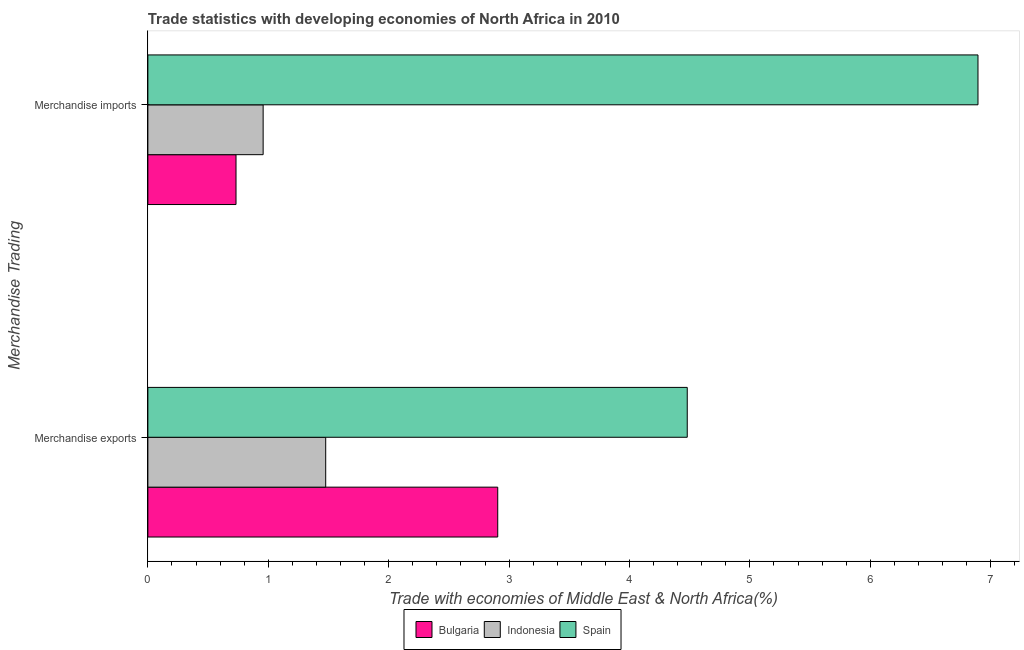How many different coloured bars are there?
Ensure brevity in your answer.  3. How many groups of bars are there?
Your answer should be compact. 2. Are the number of bars per tick equal to the number of legend labels?
Provide a succinct answer. Yes. Are the number of bars on each tick of the Y-axis equal?
Ensure brevity in your answer.  Yes. How many bars are there on the 1st tick from the bottom?
Offer a very short reply. 3. What is the label of the 2nd group of bars from the top?
Provide a short and direct response. Merchandise exports. What is the merchandise imports in Indonesia?
Give a very brief answer. 0.96. Across all countries, what is the maximum merchandise exports?
Make the answer very short. 4.48. Across all countries, what is the minimum merchandise exports?
Provide a succinct answer. 1.48. In which country was the merchandise exports maximum?
Provide a short and direct response. Spain. In which country was the merchandise imports minimum?
Your response must be concise. Bulgaria. What is the total merchandise imports in the graph?
Provide a short and direct response. 8.58. What is the difference between the merchandise imports in Spain and that in Bulgaria?
Give a very brief answer. 6.16. What is the difference between the merchandise exports in Bulgaria and the merchandise imports in Indonesia?
Provide a short and direct response. 1.95. What is the average merchandise imports per country?
Offer a terse response. 2.86. What is the difference between the merchandise exports and merchandise imports in Spain?
Give a very brief answer. -2.41. What is the ratio of the merchandise exports in Indonesia to that in Spain?
Give a very brief answer. 0.33. Is the merchandise exports in Indonesia less than that in Spain?
Your response must be concise. Yes. What does the 3rd bar from the top in Merchandise exports represents?
Provide a short and direct response. Bulgaria. Are all the bars in the graph horizontal?
Offer a terse response. Yes. How many countries are there in the graph?
Offer a terse response. 3. What is the difference between two consecutive major ticks on the X-axis?
Provide a succinct answer. 1. Does the graph contain grids?
Your response must be concise. No. What is the title of the graph?
Ensure brevity in your answer.  Trade statistics with developing economies of North Africa in 2010. What is the label or title of the X-axis?
Your response must be concise. Trade with economies of Middle East & North Africa(%). What is the label or title of the Y-axis?
Make the answer very short. Merchandise Trading. What is the Trade with economies of Middle East & North Africa(%) in Bulgaria in Merchandise exports?
Offer a very short reply. 2.91. What is the Trade with economies of Middle East & North Africa(%) of Indonesia in Merchandise exports?
Make the answer very short. 1.48. What is the Trade with economies of Middle East & North Africa(%) of Spain in Merchandise exports?
Ensure brevity in your answer.  4.48. What is the Trade with economies of Middle East & North Africa(%) in Bulgaria in Merchandise imports?
Ensure brevity in your answer.  0.73. What is the Trade with economies of Middle East & North Africa(%) of Indonesia in Merchandise imports?
Offer a terse response. 0.96. What is the Trade with economies of Middle East & North Africa(%) of Spain in Merchandise imports?
Give a very brief answer. 6.89. Across all Merchandise Trading, what is the maximum Trade with economies of Middle East & North Africa(%) of Bulgaria?
Your answer should be compact. 2.91. Across all Merchandise Trading, what is the maximum Trade with economies of Middle East & North Africa(%) in Indonesia?
Keep it short and to the point. 1.48. Across all Merchandise Trading, what is the maximum Trade with economies of Middle East & North Africa(%) of Spain?
Your answer should be very brief. 6.89. Across all Merchandise Trading, what is the minimum Trade with economies of Middle East & North Africa(%) of Bulgaria?
Offer a terse response. 0.73. Across all Merchandise Trading, what is the minimum Trade with economies of Middle East & North Africa(%) in Indonesia?
Ensure brevity in your answer.  0.96. Across all Merchandise Trading, what is the minimum Trade with economies of Middle East & North Africa(%) in Spain?
Your response must be concise. 4.48. What is the total Trade with economies of Middle East & North Africa(%) of Bulgaria in the graph?
Provide a succinct answer. 3.64. What is the total Trade with economies of Middle East & North Africa(%) of Indonesia in the graph?
Give a very brief answer. 2.43. What is the total Trade with economies of Middle East & North Africa(%) in Spain in the graph?
Give a very brief answer. 11.37. What is the difference between the Trade with economies of Middle East & North Africa(%) in Bulgaria in Merchandise exports and that in Merchandise imports?
Your answer should be compact. 2.17. What is the difference between the Trade with economies of Middle East & North Africa(%) in Indonesia in Merchandise exports and that in Merchandise imports?
Make the answer very short. 0.52. What is the difference between the Trade with economies of Middle East & North Africa(%) in Spain in Merchandise exports and that in Merchandise imports?
Offer a terse response. -2.41. What is the difference between the Trade with economies of Middle East & North Africa(%) in Bulgaria in Merchandise exports and the Trade with economies of Middle East & North Africa(%) in Indonesia in Merchandise imports?
Provide a succinct answer. 1.95. What is the difference between the Trade with economies of Middle East & North Africa(%) of Bulgaria in Merchandise exports and the Trade with economies of Middle East & North Africa(%) of Spain in Merchandise imports?
Offer a terse response. -3.99. What is the difference between the Trade with economies of Middle East & North Africa(%) of Indonesia in Merchandise exports and the Trade with economies of Middle East & North Africa(%) of Spain in Merchandise imports?
Offer a terse response. -5.42. What is the average Trade with economies of Middle East & North Africa(%) of Bulgaria per Merchandise Trading?
Offer a terse response. 1.82. What is the average Trade with economies of Middle East & North Africa(%) in Indonesia per Merchandise Trading?
Your answer should be very brief. 1.22. What is the average Trade with economies of Middle East & North Africa(%) in Spain per Merchandise Trading?
Make the answer very short. 5.69. What is the difference between the Trade with economies of Middle East & North Africa(%) of Bulgaria and Trade with economies of Middle East & North Africa(%) of Indonesia in Merchandise exports?
Provide a short and direct response. 1.43. What is the difference between the Trade with economies of Middle East & North Africa(%) of Bulgaria and Trade with economies of Middle East & North Africa(%) of Spain in Merchandise exports?
Provide a succinct answer. -1.57. What is the difference between the Trade with economies of Middle East & North Africa(%) in Indonesia and Trade with economies of Middle East & North Africa(%) in Spain in Merchandise exports?
Offer a very short reply. -3. What is the difference between the Trade with economies of Middle East & North Africa(%) in Bulgaria and Trade with economies of Middle East & North Africa(%) in Indonesia in Merchandise imports?
Your answer should be very brief. -0.23. What is the difference between the Trade with economies of Middle East & North Africa(%) of Bulgaria and Trade with economies of Middle East & North Africa(%) of Spain in Merchandise imports?
Your answer should be very brief. -6.16. What is the difference between the Trade with economies of Middle East & North Africa(%) in Indonesia and Trade with economies of Middle East & North Africa(%) in Spain in Merchandise imports?
Give a very brief answer. -5.94. What is the ratio of the Trade with economies of Middle East & North Africa(%) of Bulgaria in Merchandise exports to that in Merchandise imports?
Offer a very short reply. 3.97. What is the ratio of the Trade with economies of Middle East & North Africa(%) in Indonesia in Merchandise exports to that in Merchandise imports?
Ensure brevity in your answer.  1.54. What is the ratio of the Trade with economies of Middle East & North Africa(%) of Spain in Merchandise exports to that in Merchandise imports?
Keep it short and to the point. 0.65. What is the difference between the highest and the second highest Trade with economies of Middle East & North Africa(%) in Bulgaria?
Provide a short and direct response. 2.17. What is the difference between the highest and the second highest Trade with economies of Middle East & North Africa(%) in Indonesia?
Give a very brief answer. 0.52. What is the difference between the highest and the second highest Trade with economies of Middle East & North Africa(%) in Spain?
Your answer should be compact. 2.41. What is the difference between the highest and the lowest Trade with economies of Middle East & North Africa(%) in Bulgaria?
Your response must be concise. 2.17. What is the difference between the highest and the lowest Trade with economies of Middle East & North Africa(%) in Indonesia?
Ensure brevity in your answer.  0.52. What is the difference between the highest and the lowest Trade with economies of Middle East & North Africa(%) in Spain?
Your answer should be compact. 2.41. 